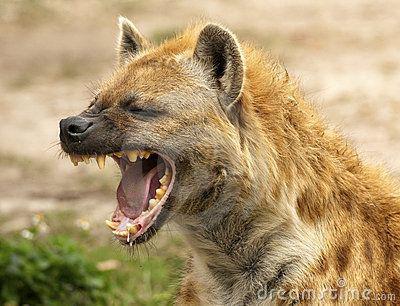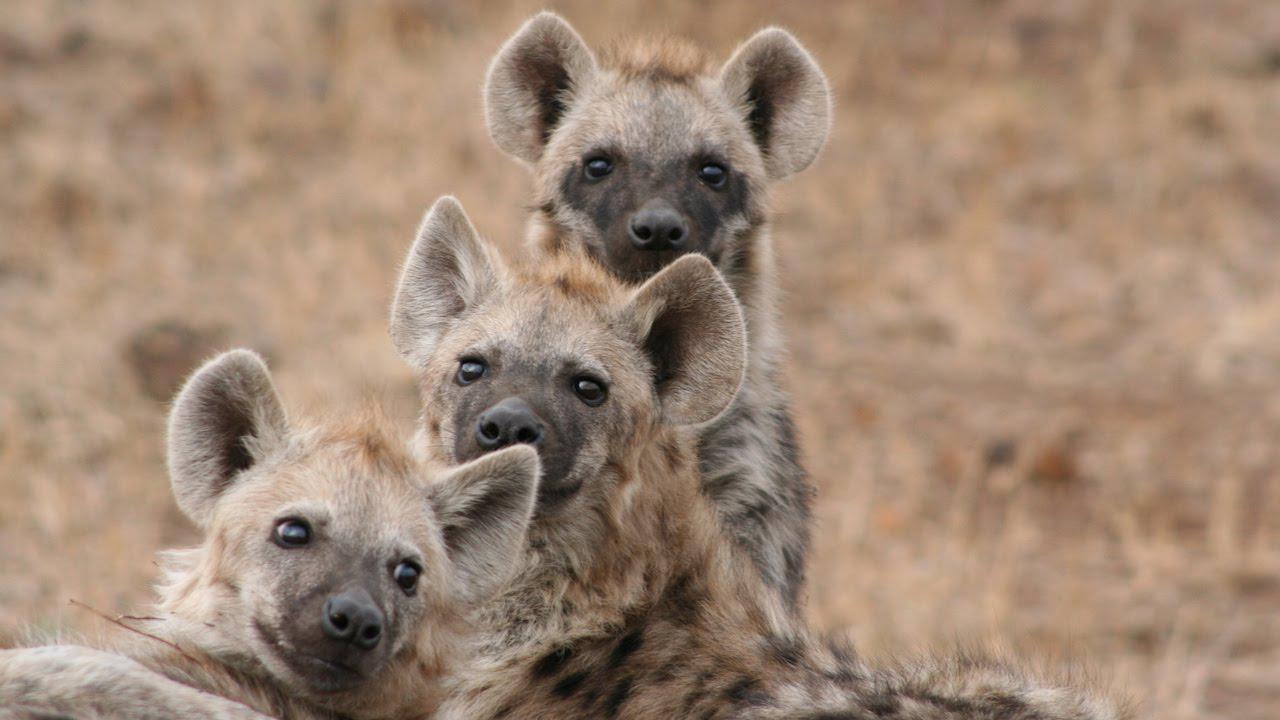The first image is the image on the left, the second image is the image on the right. Evaluate the accuracy of this statement regarding the images: "Out of the two animals, one of them has its mouth wide open.". Is it true? Answer yes or no. No. The first image is the image on the left, the second image is the image on the right. Assess this claim about the two images: "Right image shows exactly one hyena, which is baring its fangs.". Correct or not? Answer yes or no. No. 